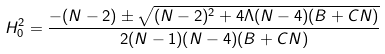Convert formula to latex. <formula><loc_0><loc_0><loc_500><loc_500>H _ { 0 } ^ { 2 } = \frac { - ( N - 2 ) \pm \sqrt { ( N - 2 ) ^ { 2 } + 4 \Lambda ( N - 4 ) ( B + C N ) } } { 2 ( N - 1 ) ( N - 4 ) ( B + C N ) }</formula> 